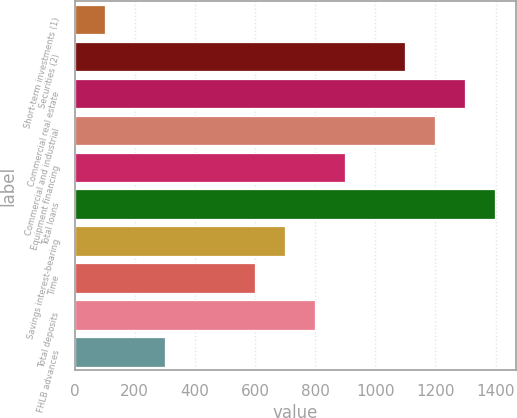Convert chart. <chart><loc_0><loc_0><loc_500><loc_500><bar_chart><fcel>Short-term investments (1)<fcel>Securities (2)<fcel>Commercial real estate<fcel>Commercial and industrial<fcel>Equipment financing<fcel>Total loans<fcel>Savings interest-bearing<fcel>Time<fcel>Total deposits<fcel>FHLB advances<nl><fcel>100.56<fcel>1099.16<fcel>1298.88<fcel>1199.02<fcel>899.44<fcel>1398.74<fcel>699.72<fcel>599.86<fcel>799.58<fcel>300.28<nl></chart> 